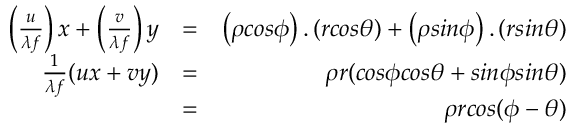<formula> <loc_0><loc_0><loc_500><loc_500>\begin{array} { r l r } { \left ( \frac { u } { \lambda f } \right ) x + \left ( \frac { v } { \lambda f } \right ) y } & { = } & { \left ( \rho \cos \phi \right ) . \left ( r \cos \theta \right ) + \left ( \rho \sin \phi \right ) . \left ( r \sin \theta \right ) } \\ { \frac { 1 } { \lambda f } ( u x + v y ) } & { = } & { \rho r ( \cos \phi \cos \theta + \sin \phi \sin \theta ) } \\ & { = } & { \rho r \cos ( \phi - \theta ) } \end{array}</formula> 